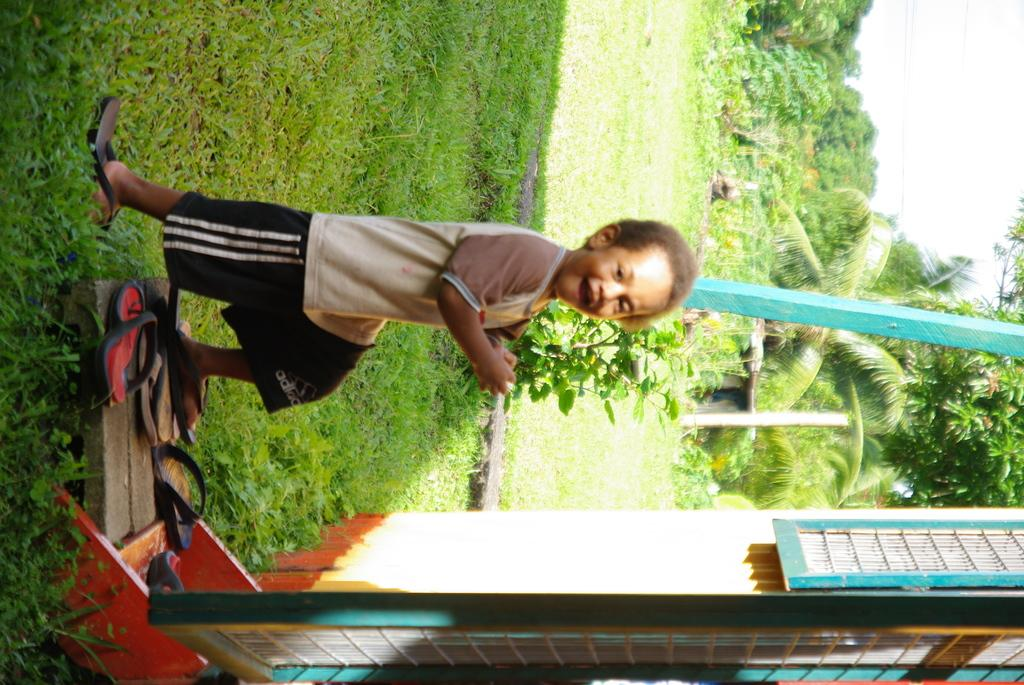Who is the main subject in the picture? There is a boy in the picture. What is the boy doing in the picture? The boy is standing. What is the boy wearing in the picture? The boy is wearing a t-shirt and trousers. What can be seen in the backdrop of the picture? There are plants and trees in the backdrop of the picture. What is located on the left side of the picture? There is a building on the left side of the picture. What is the boy saying in the picture? The image does not provide any information about what the boy might be saying, as it does not include any audio or text. 